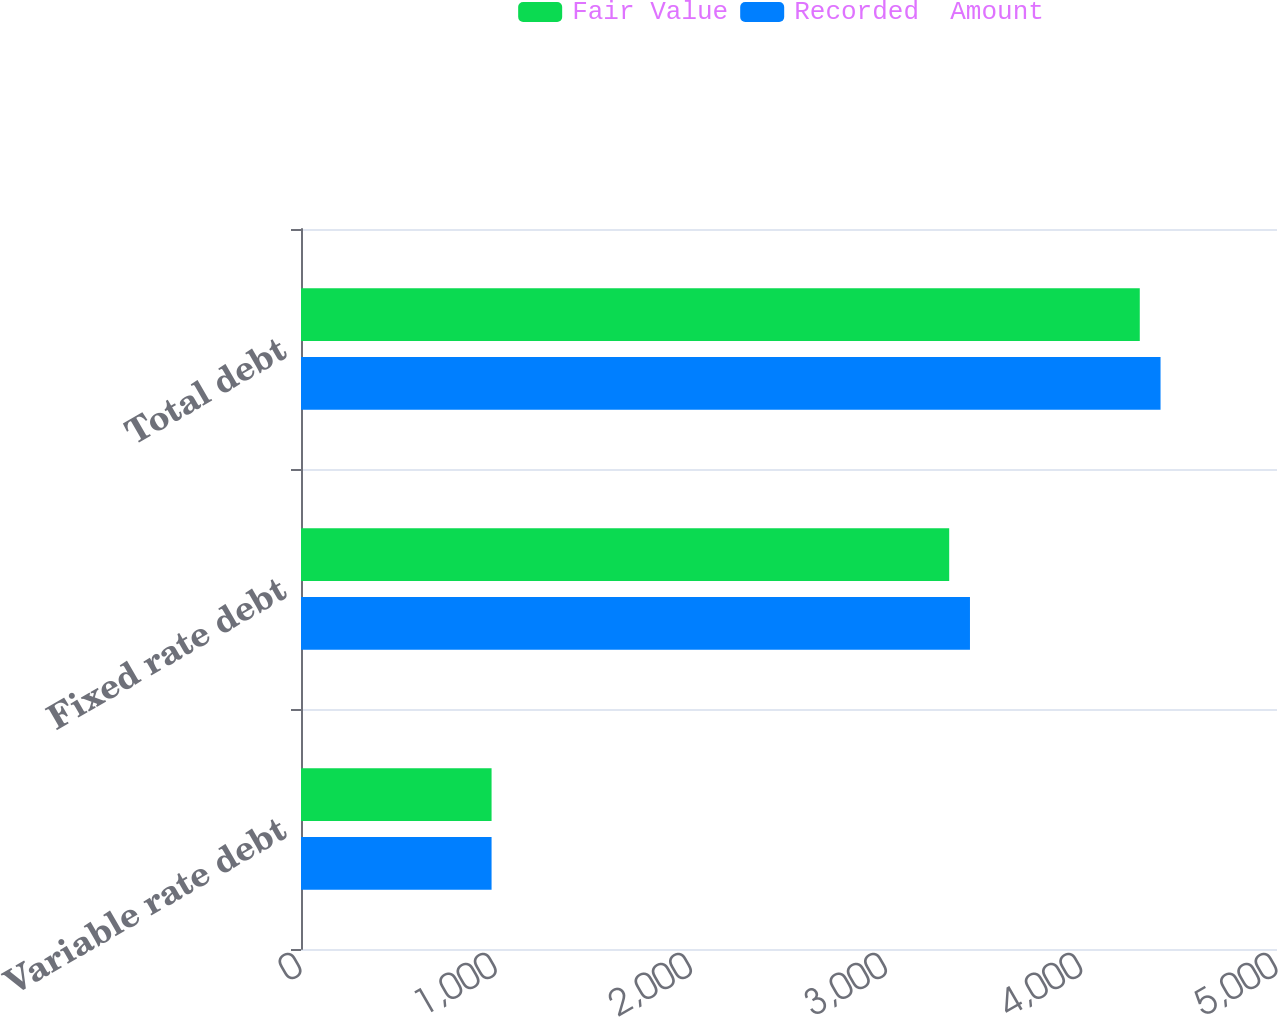Convert chart to OTSL. <chart><loc_0><loc_0><loc_500><loc_500><stacked_bar_chart><ecel><fcel>Variable rate debt<fcel>Fixed rate debt<fcel>Total debt<nl><fcel>Fair Value<fcel>976.3<fcel>3320.7<fcel>4297<nl><fcel>Recorded  Amount<fcel>976.3<fcel>3427.1<fcel>4403.4<nl></chart> 